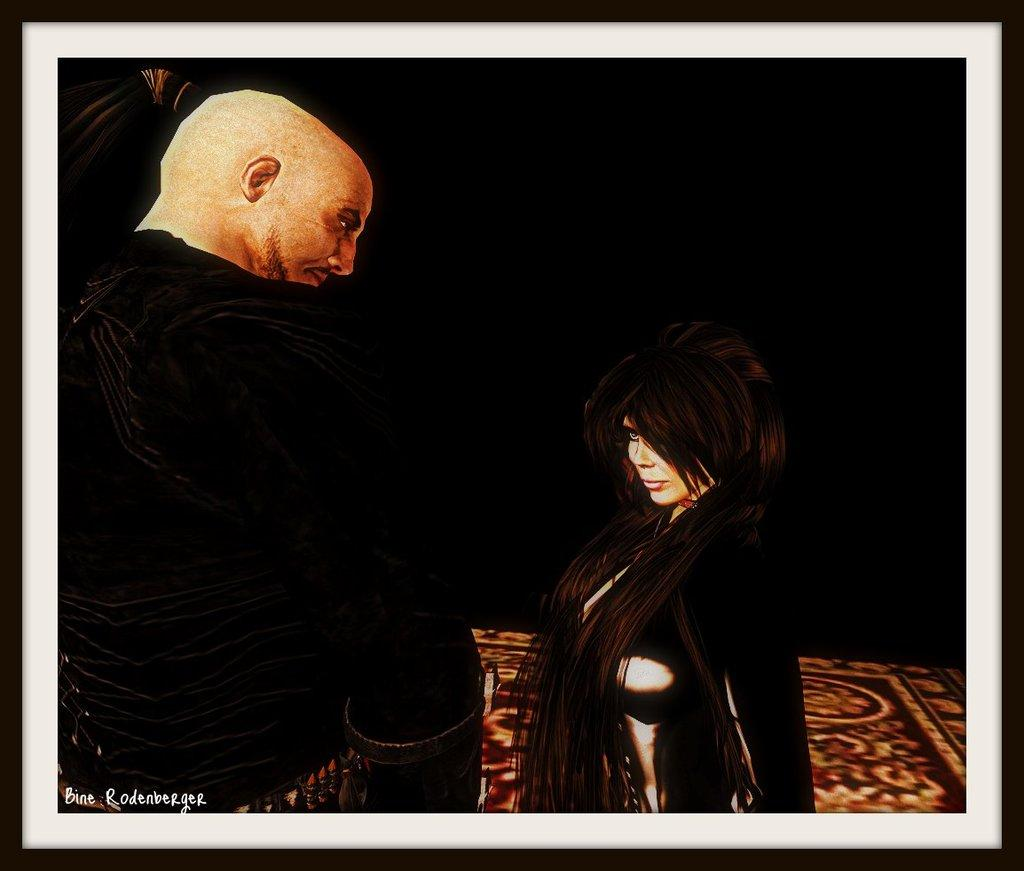What object in the image contains a photo? There is a photo frame in the image. How many persons are in the photo inside the frame? The photo in the frame contains two persons. What is the color of the background in the image? The background of the image is dark. Where is the text located in the image? The text is in the bottom left corner of the image. What type of yarn is being used to create the art in the image? There is no yarn or art present in the image. What side of the photo frame is being displayed? The facts provided do not specify which side of the photo frame is being displayed. 